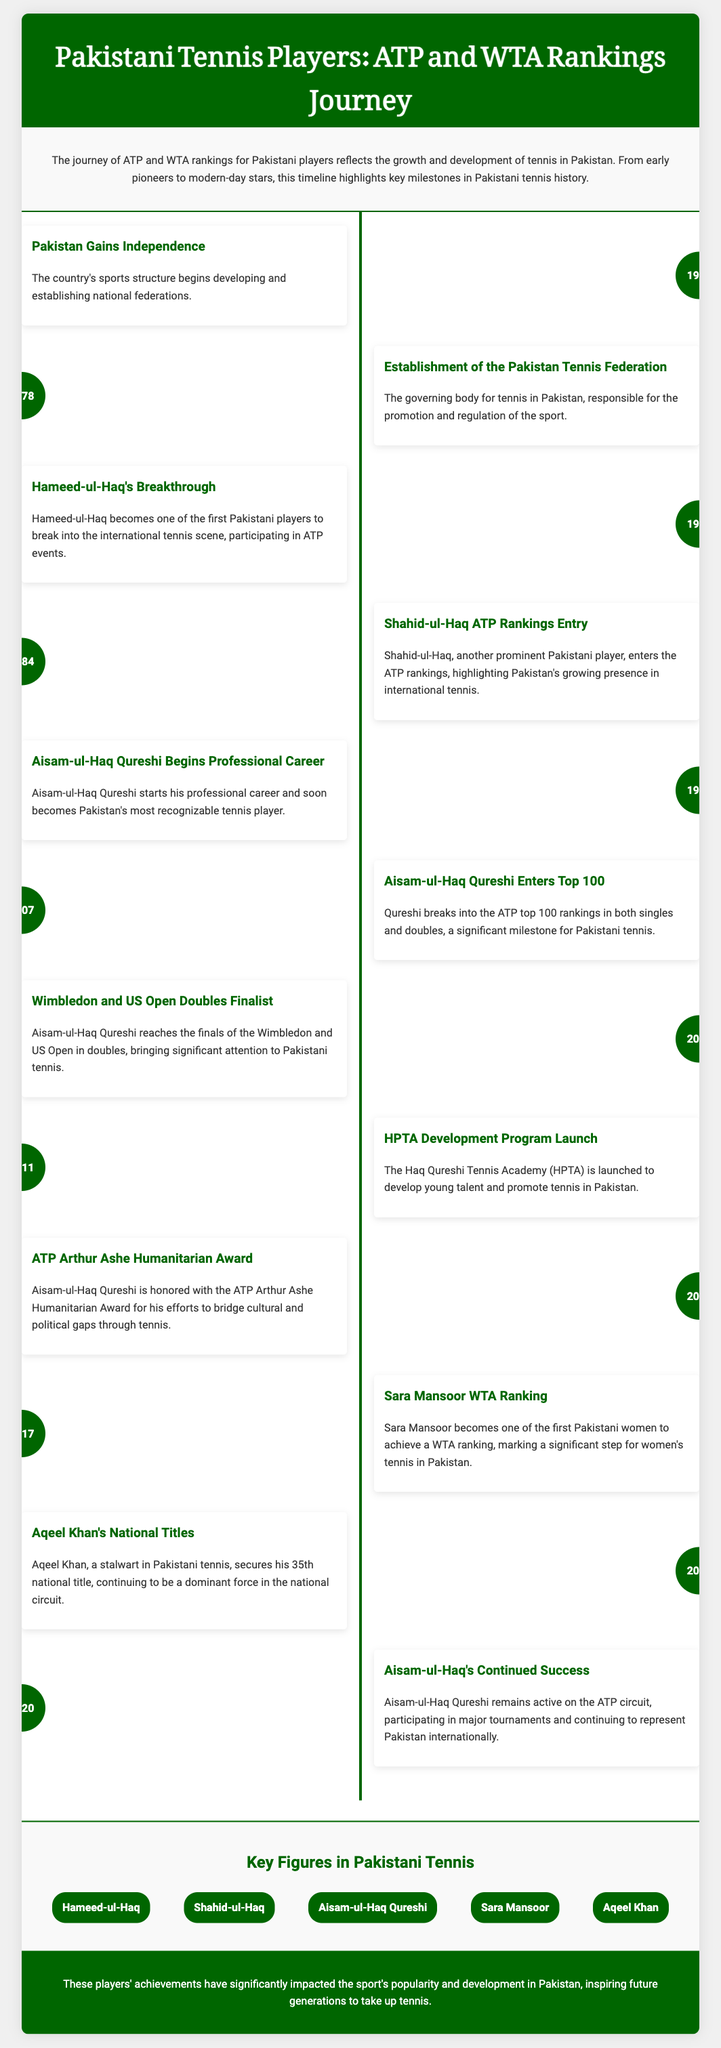What year did Pakistan gain independence? The timeline states that Pakistan gained independence in 1947, indicating the starting point for its sports structure development.
Answer: 1947 Who established the Pakistan Tennis Federation? The document does not specify a particular individual but notes that it was established as the governing body for tennis in Pakistan in 1978.
Answer: 1978 Which Pakistani player broke into the ATP rankings in 1984? Shahid-ul-Haq's entry into the ATP rankings in 1984 is highlighted as a key milestone for Pakistani tennis.
Answer: Shahid-ul-Haq What significant event occurred in 2010? Aisam-ul-Haq Qureshi reached the finals of both Wimbledon and US Open in doubles, marking a notable achievement for Pakistani tennis.
Answer: Wimbledon and US Open Doubles Finalist Which award did Aisam-ul-Haq Qureshi receive in 2012? The document highlights that Aisam-ul-Haq Qureshi was honored with the ATP Arthur Ashe Humanitarian Award in 2012.
Answer: ATP Arthur Ashe Humanitarian Award In what year did Sara Mansoor achieve a WTA ranking? The timeline indicates that Sara Mansoor became one of the first Pakistani women to achieve a WTA ranking in 2017.
Answer: 2017 How many national titles did Aqeel Khan secure by 2019? Aqeel Khan secured his 35th national title by 2019, demonstrating his dominance in the national tennis circuit.
Answer: 35 What does HPTA stand for? HPTA refers to the Haq Qureshi Tennis Academy, which was launched in 2011 to develop young tennis talent in Pakistan.
Answer: Haq Qureshi Tennis Academy What career milestone did Aisam-ul-Haq Qureshi achieve in 2007? The document states that Aisam-ul-Haq Qureshi broke into the ATP top 100 rankings in both singles and doubles in 2007.
Answer: ATP top 100 